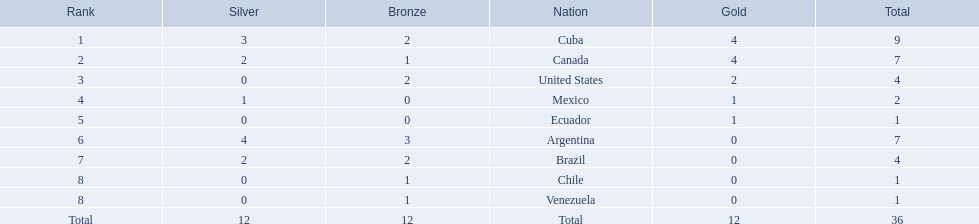What were the amounts of bronze medals won by the countries? 2, 1, 2, 0, 0, 3, 2, 1, 1. Which is the highest? 3. Which nation had this amount? Argentina. 